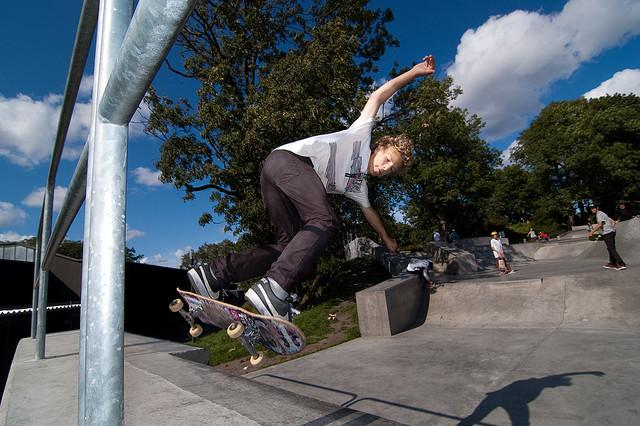What will happen to the boy next? landing 